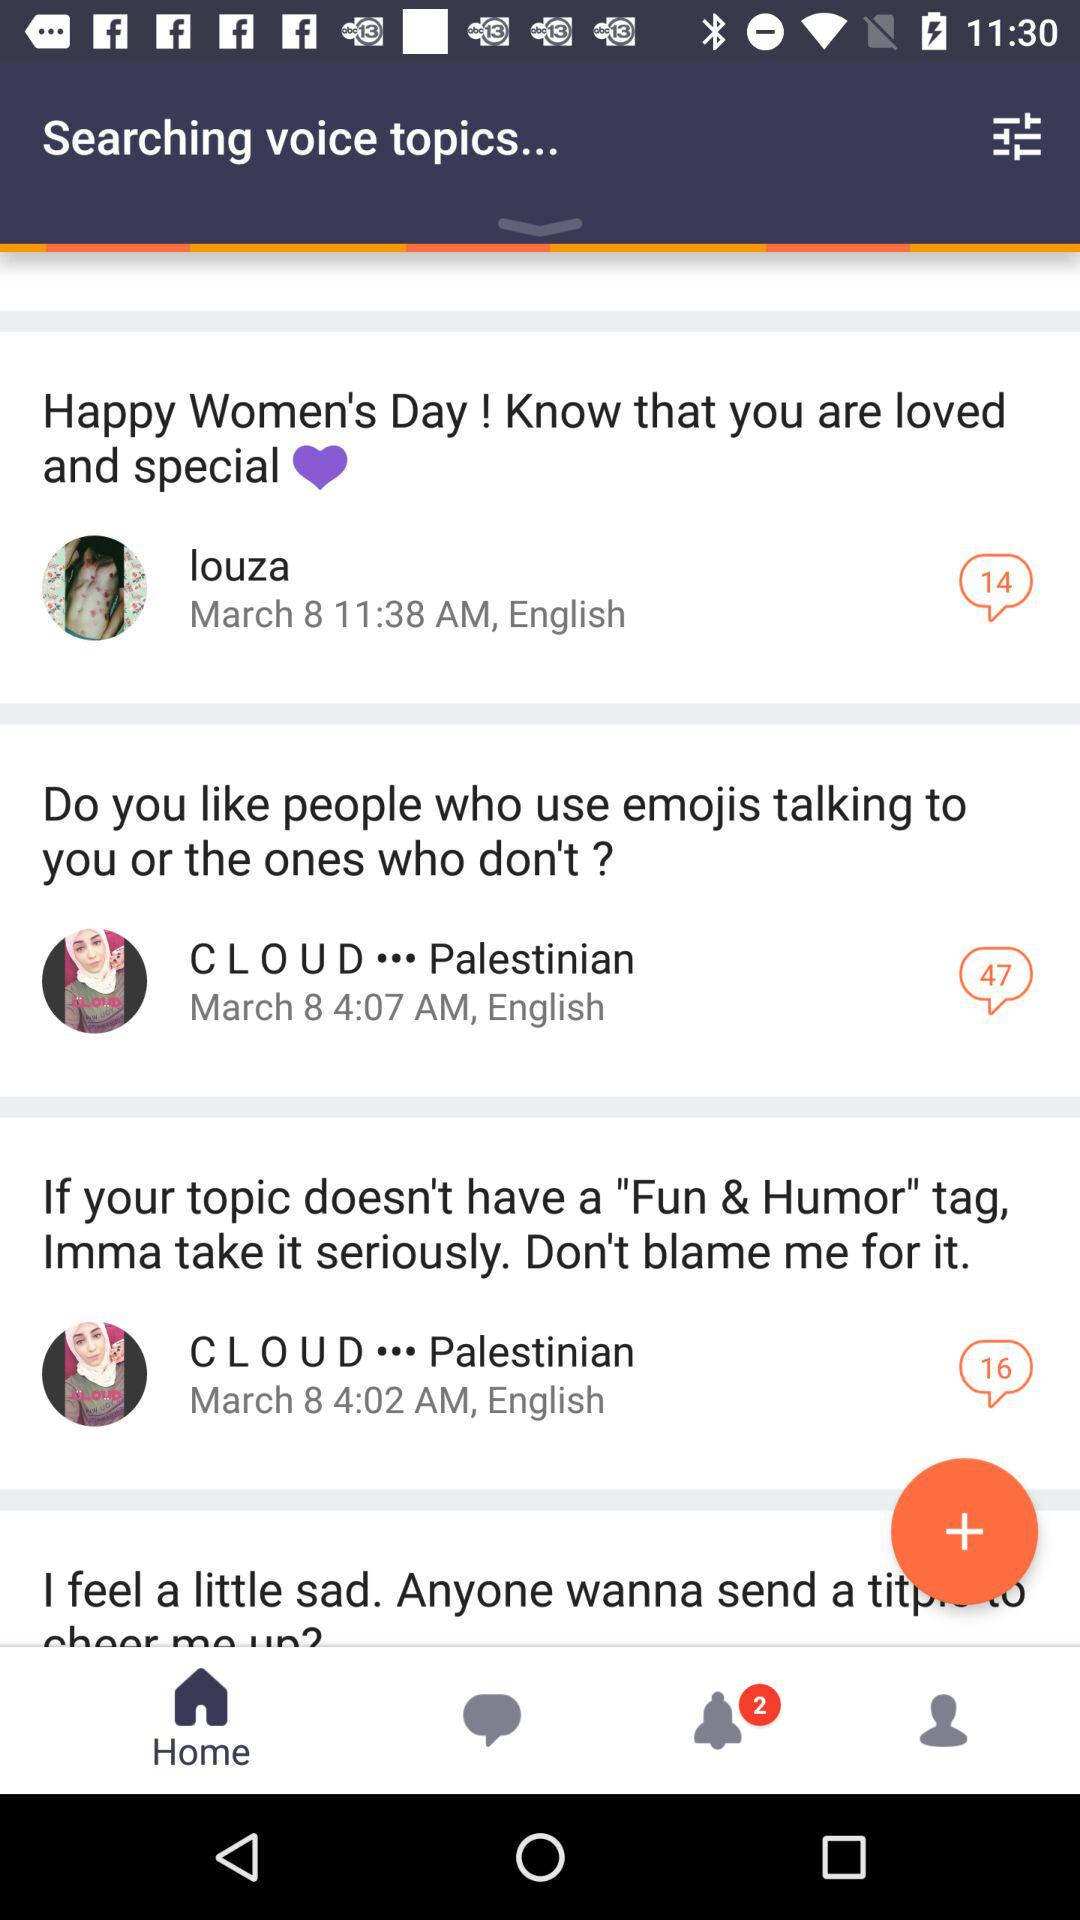How many comments are there for the post about people who use emojis while talking, posted by "C L O U D"? There are 47 comments for the post about people who use emojis while talking, posted by "C L O U D". 